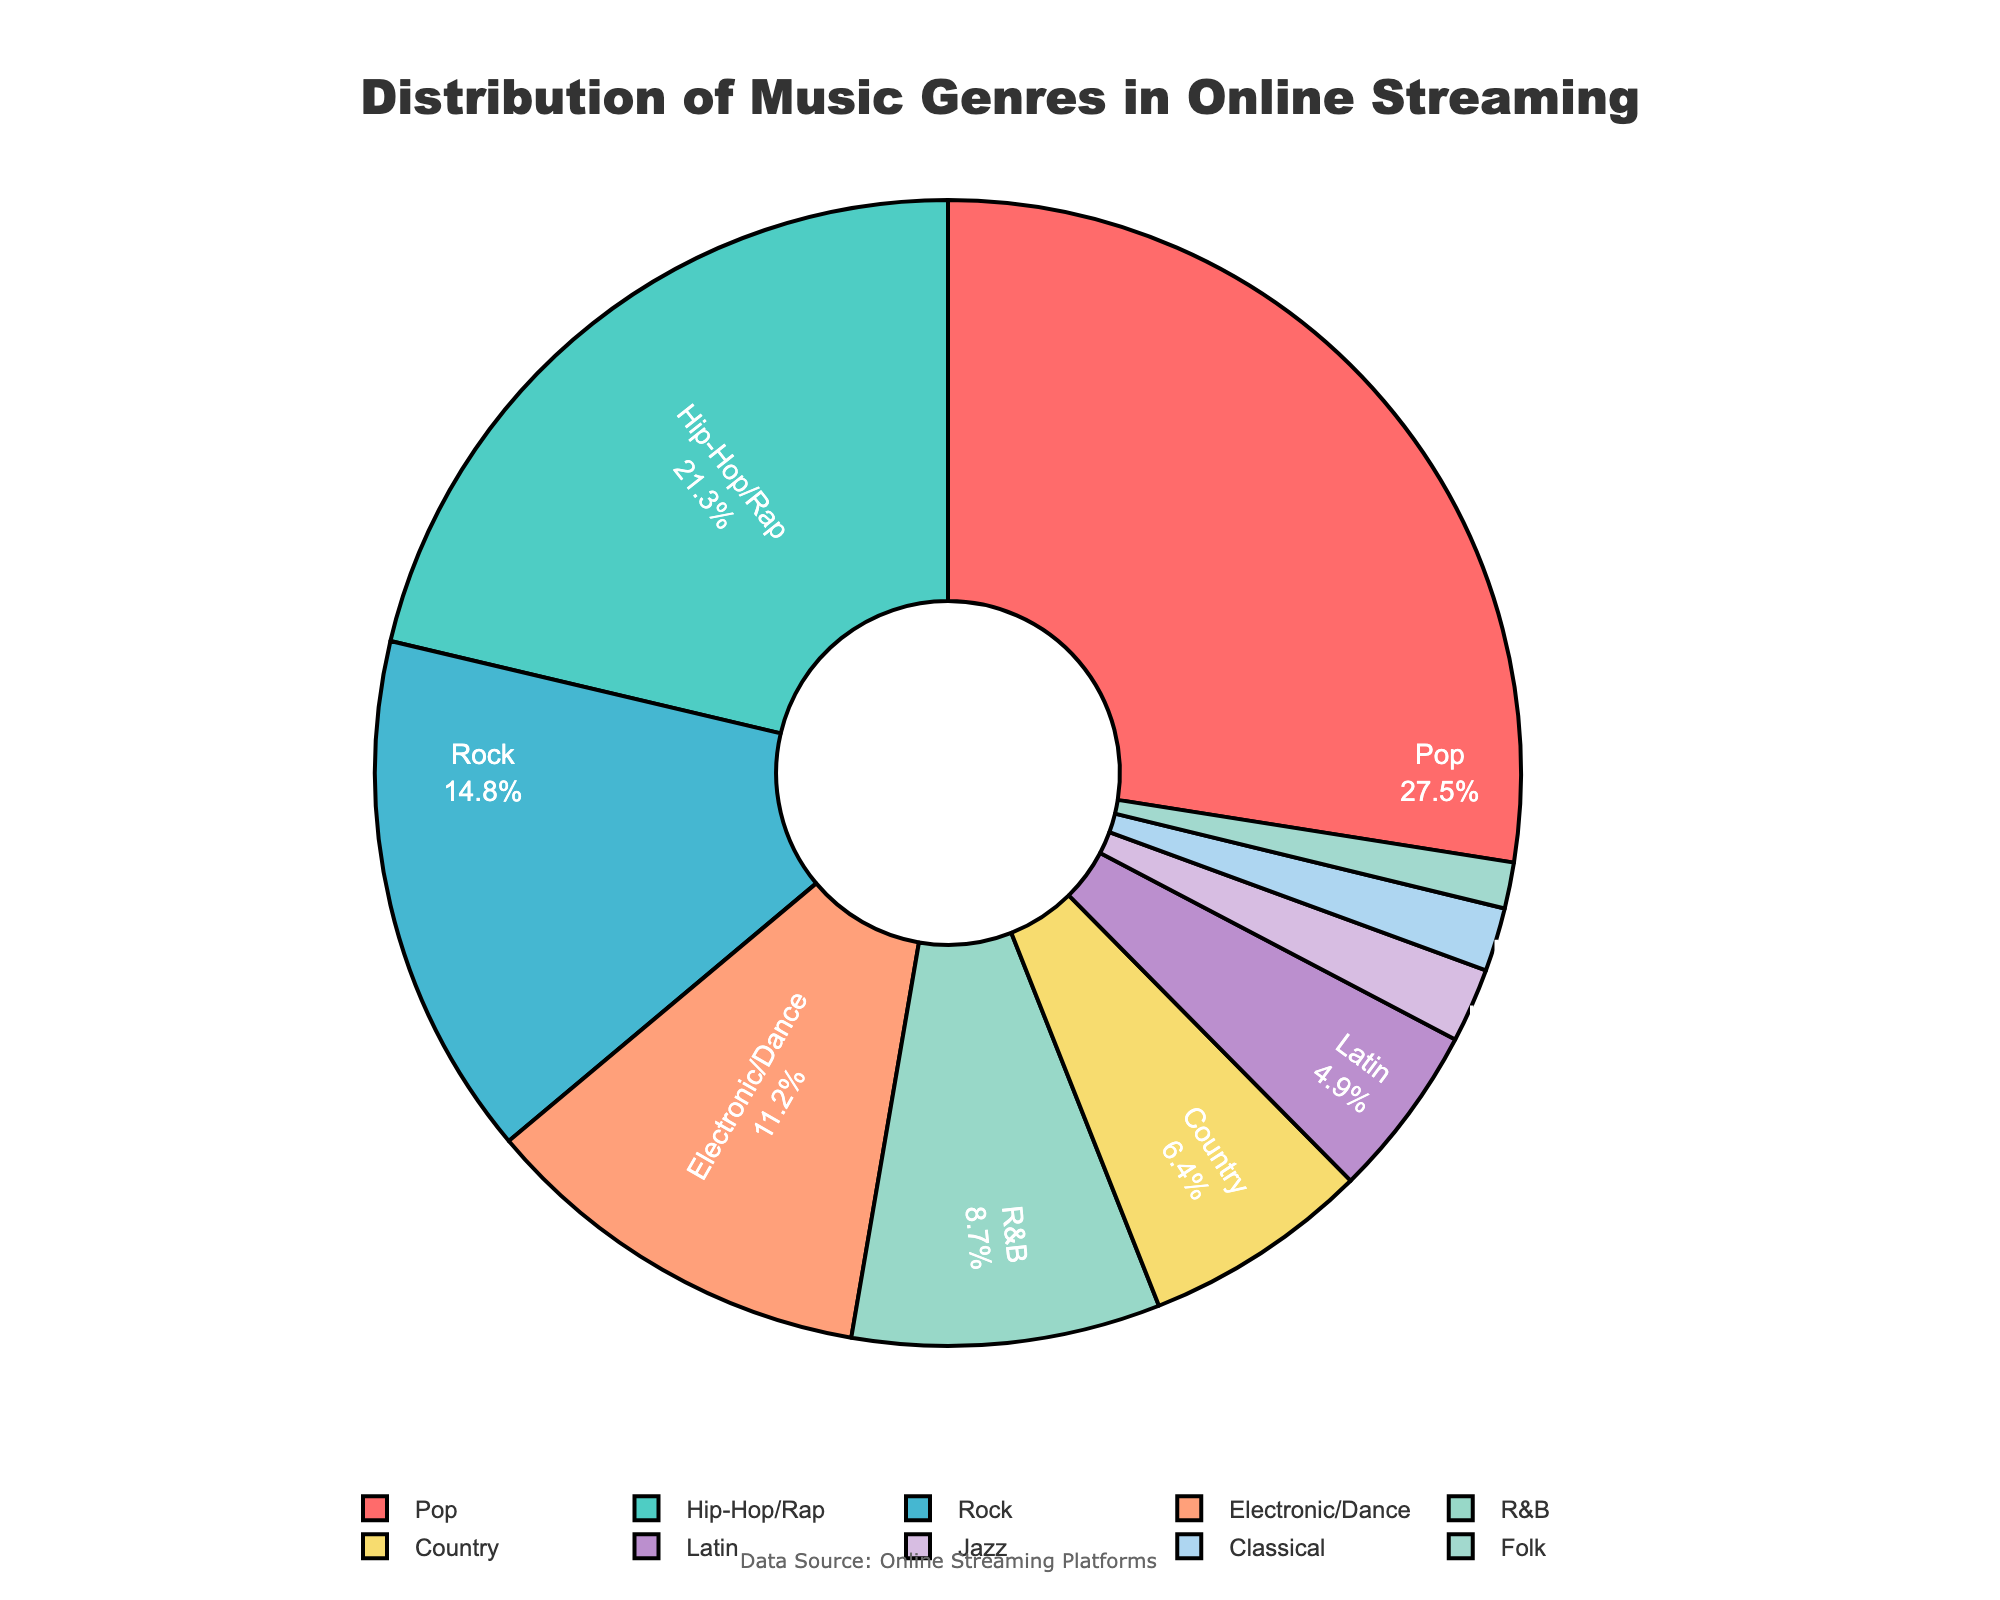Which genre has the highest percentage in the distribution of music genres? By observing the pie chart, the genre with the largest section should have the highest percentage. The section labeled 'Pop' takes up the largest proportion of the pie chart.
Answer: Pop Which genre has the smallest percentage in the distribution? By looking for the smallest segment in the pie chart, the genre labeled 'Folk' occupies the least space in the chart.
Answer: Folk How much larger is the percentage of Pop compared to Classical? The percentage of Pop is 27.5%, and the percentage of Classical is 1.8%. The difference in percentage is calculated as 27.5% - 1.8% = 25.7%.
Answer: 25.7% Add the percentages of the three least popular genres and state the total. The percentages for Jazz, Classical, and Folk are 2.1%, 1.8%, and 1.3%, respectively. Adding them gives 2.1% + 1.8% + 1.3% = 5.2%.
Answer: 5.2% Which genre has a larger percentage, Hip-Hop/Rap or Rock? By how much? Hip-Hop/Rap has a percentage of 21.3%, and Rock has a percentage of 14.8%. The difference between them is 21.3% - 14.8% = 6.5%.
Answer: Hip-Hop/Rap by 6.5% What is the combined percentage of Pop, Hip-Hop/Rap, and Rock? The percentages of Pop, Hip-Hop/Rap, and Rock are 27.5%, 21.3%, and 14.8%, respectively. The combined percentage is 27.5% + 21.3% + 14.8% = 63.6%.
Answer: 63.6% Which color represents the genre 'Electronic/Dance'? The genre 'Electronic/Dance' is represented by the fourth color in the custom color palette used in the figure. On inspection of the pie chart, Electronic/Dance is colored light orange.
Answer: light orange How many genres have a percentage greater than 10%? By checking the labels and their corresponding percentages, genres with values above 10% are Pop, Hip-Hop/Rap, and Rock. In total, there are 3 genres.
Answer: 3 Calculate the difference in percentage between the most popular and the least popular genre. The most popular genre, Pop, has 27.5%, and the least popular genre, Folk, has 1.3%. The difference is 27.5% - 1.3% = 26.2%.
Answer: 26.2% What is the average percentage of the genres labeled Pop, Hip-Hop/Rap, and Electronic/Dance? The percentages of Pop, Hip-Hop/Rap, and Electronic/Dance are 27.5%, 21.3%, and 11.2%, respectively. The average is calculated as (27.5% + 21.3% + 11.2%) / 3 = 20%.
Answer: 20% 